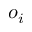Convert formula to latex. <formula><loc_0><loc_0><loc_500><loc_500>o _ { i }</formula> 